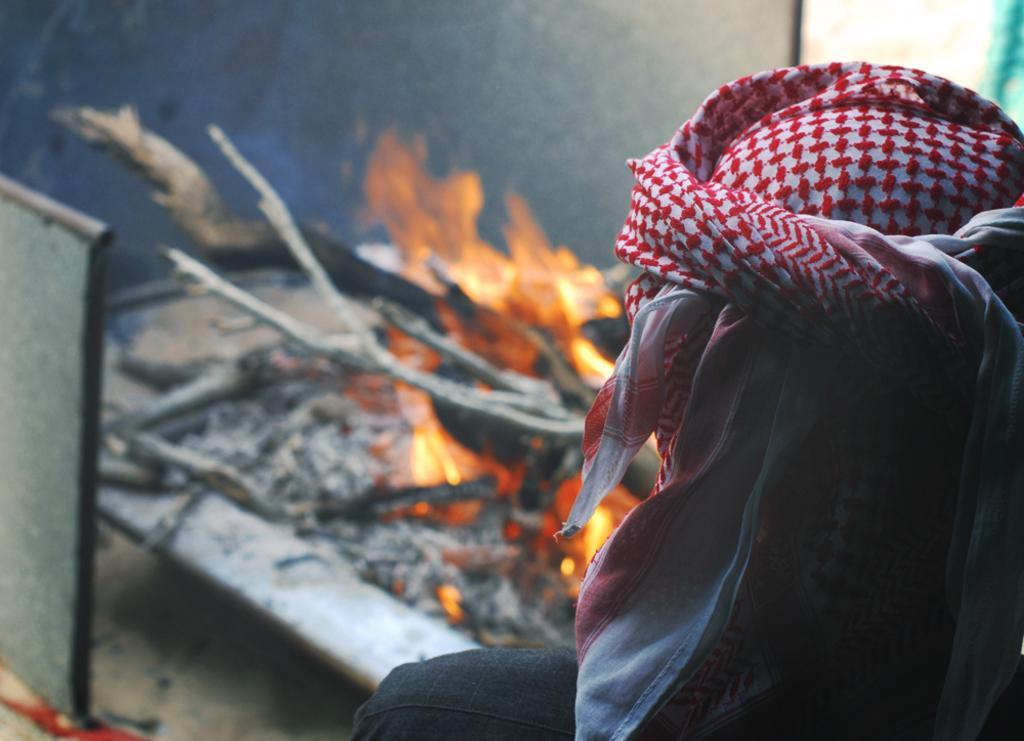Describe this image in one or two sentences. In this image, we can see a person wearing a hat. There is a flame in the middle of the image. 